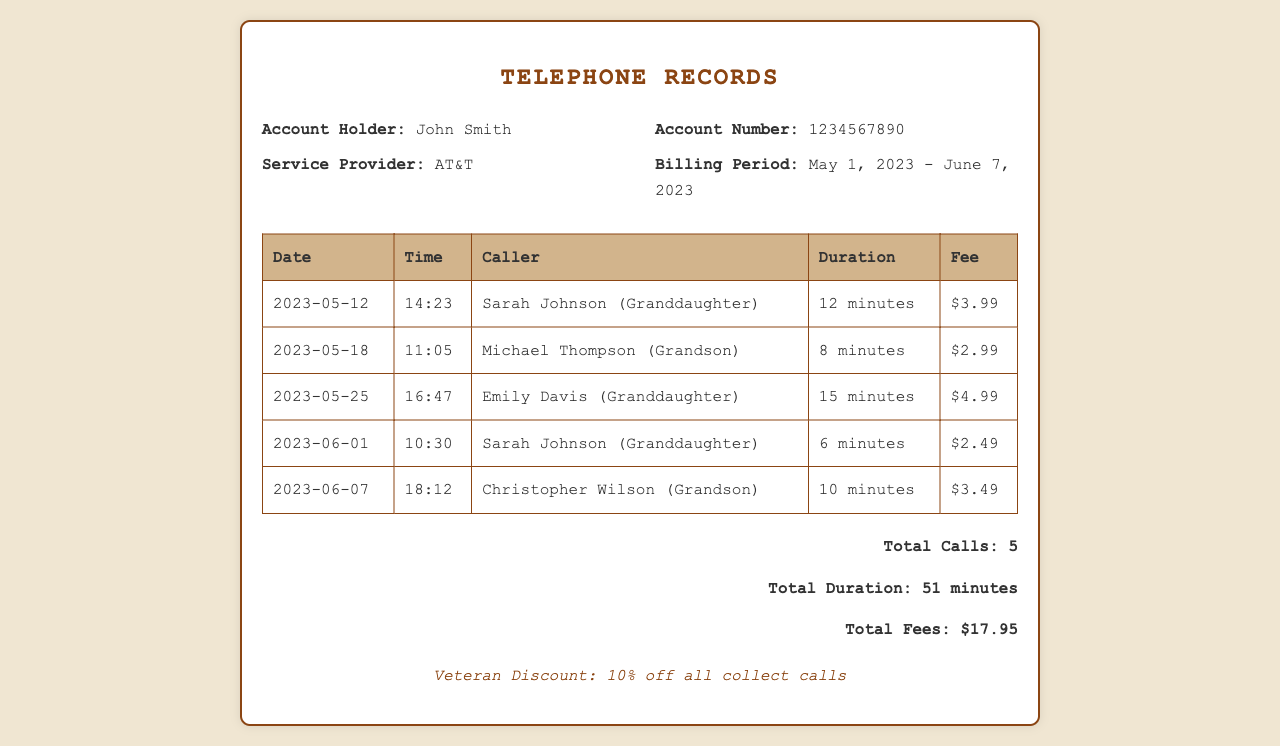What is the name of the account holder? The account holder's name is displayed at the top under the account information section.
Answer: John Smith What is the service provider listed in the document? The service provider is indicated as AT&T in the account information section.
Answer: AT&T How many total calls were received from grandchildren? The total number of calls is summarized in the total section at the bottom of the document.
Answer: 5 What was the fee for the call made by Sarah Johnson on June 1, 2023? The fee for this specific call is shown in the row corresponding to the date and caller.
Answer: $2.49 Which grandchild called the most during this billing period? To determine this, one must analyze the callers and see who appears the most in the listing.
Answer: Sarah Johnson What is the total duration of all calls received from grandchildren? The total duration is clearly summarized in the document summary section.
Answer: 51 minutes What was the date of the longest call received from a grandchild? The duration must be compared across all entries to find the longest. The date is indicated in the corresponding row.
Answer: 2023-05-25 What discount is mentioned in the document? The document specifies a discount available to the account holder as part of the summary.
Answer: 10% off all collect calls What is the fee for the call made by Emily Davis? The fee for Emily Davis's call is noted in the specific row for that call.
Answer: $4.99 